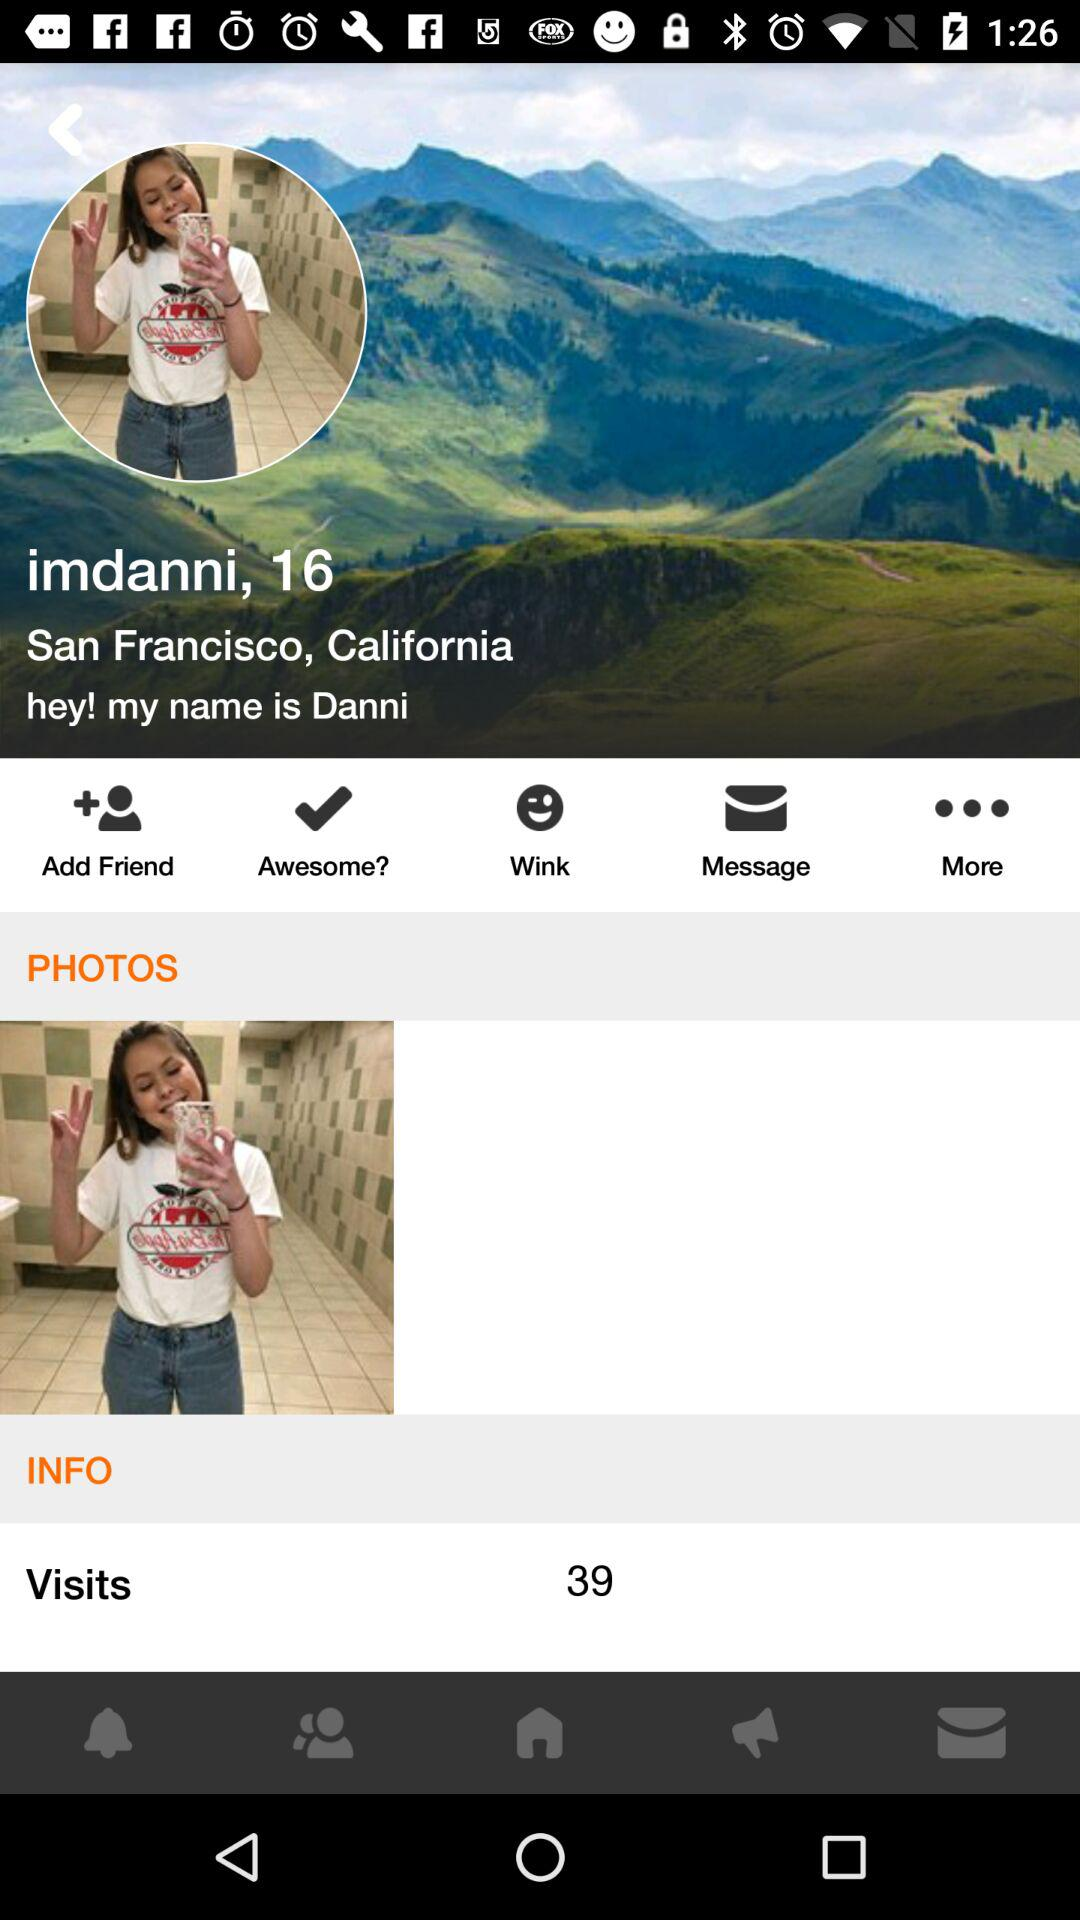What is the age of Imdanni? Imdanni is 16 years old. 